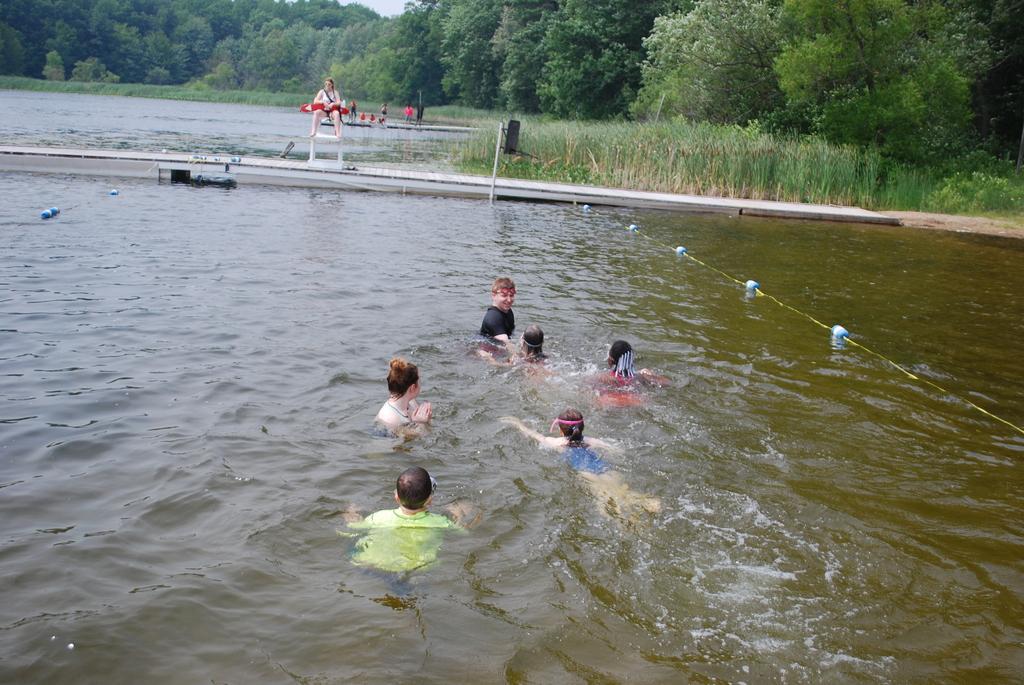In one or two sentences, can you explain what this image depicts? In this image I can see group of people in the water. In the background I can see the person and the person is wearing white color shirt and I can see few trees in green color and the sky is in white color. 